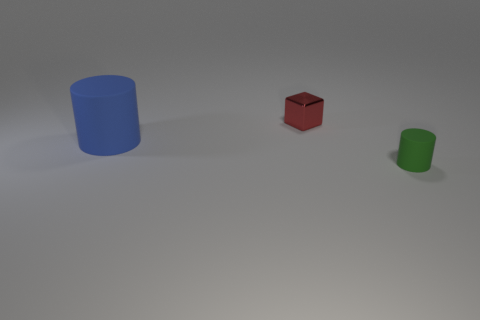Add 2 blue rubber things. How many objects exist? 5 Subtract all cylinders. How many objects are left? 1 Add 2 tiny metallic blocks. How many tiny metallic blocks are left? 3 Add 2 brown rubber balls. How many brown rubber balls exist? 2 Subtract 0 gray cubes. How many objects are left? 3 Subtract all large matte cylinders. Subtract all green cylinders. How many objects are left? 1 